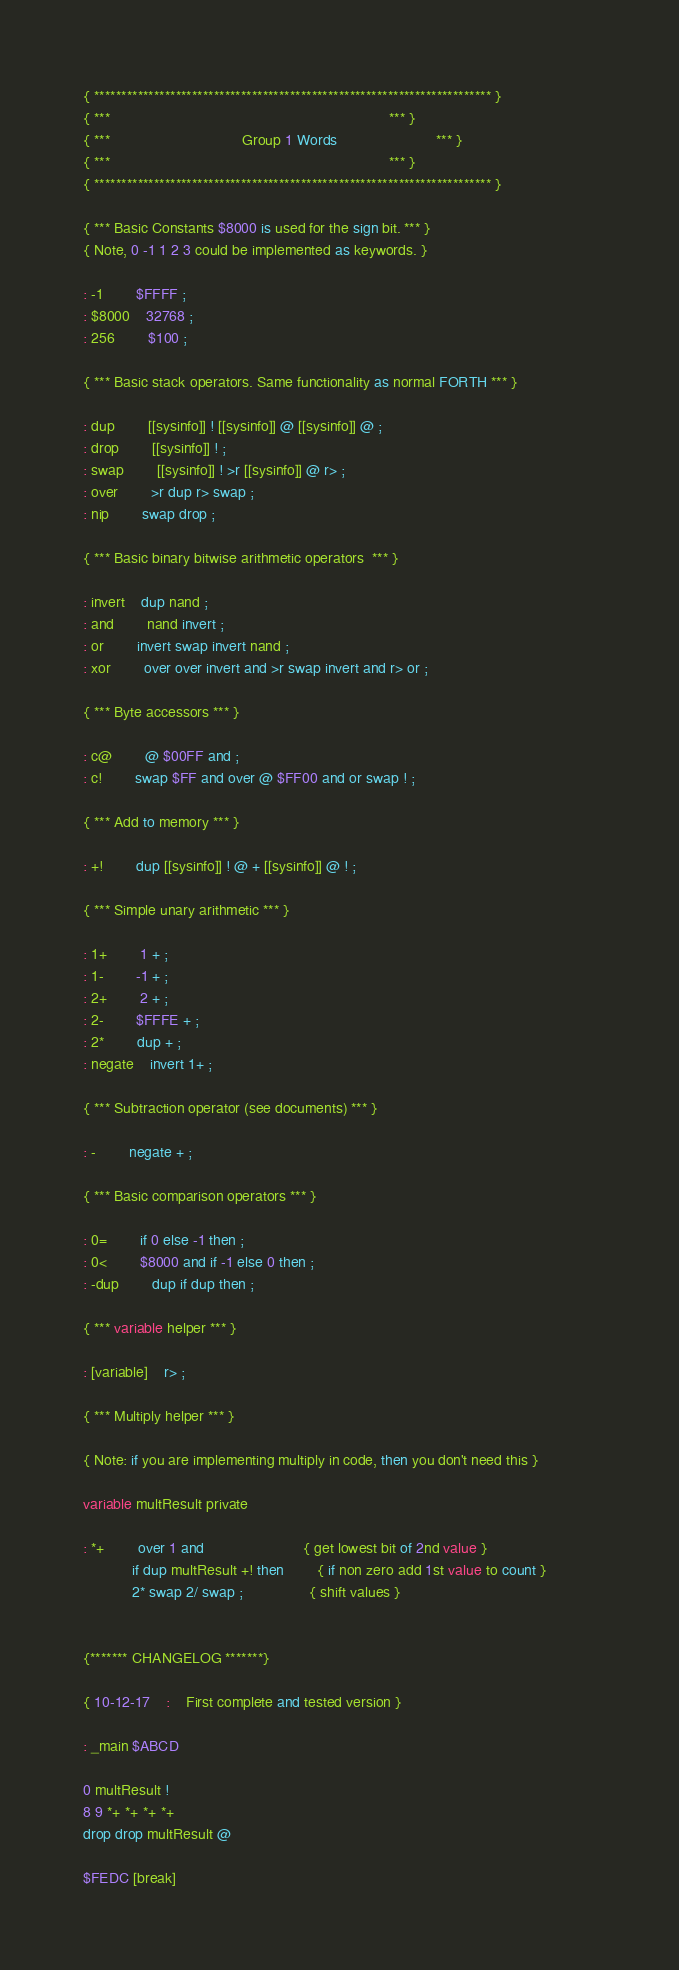<code> <loc_0><loc_0><loc_500><loc_500><_Forth_>{ ************************************************************************* }
{ ***																	*** }
{ ***								Group 1 Words						*** }
{ ***																	*** }
{ ************************************************************************* }

{ *** Basic Constants $8000 is used for the sign bit. *** }
{ Note, 0 -1 1 2 3 could be implemented as keywords. }

: -1 		$FFFF ;
: $8000 	32768 ;
: 256 		$100 ;
	
{ *** Basic stack operators. Same functionality as normal FORTH *** }

: dup		[[sysinfo]] ! [[sysinfo]] @ [[sysinfo]] @ ;
: drop 		[[sysinfo]] ! ;
: swap 		[[sysinfo]] ! >r [[sysinfo]] @ r> ;
: over 		>r dup r> swap ;
: nip 		swap drop ;

{ *** Basic binary bitwise arithmetic operators  *** }

: invert	dup nand ;
: and 		nand invert ;
: or 		invert swap invert nand ;
: xor 		over over invert and >r swap invert and r> or ;

{ *** Byte accessors *** }

: c@ 		@ $00FF and ;
: c! 		swap $FF and over @ $FF00 and or swap ! ;

{ *** Add to memory *** }

: +! 		dup [[sysinfo]] ! @ + [[sysinfo]] @ ! ;

{ *** Simple unary arithmetic *** }

: 1+ 		1 + ;
: 1- 		-1 + ;
: 2+ 		2 + ;
: 2- 		$FFFE + ;
: 2* 		dup + ;
: negate	invert 1+ ;

{ *** Subtraction operator (see documents) *** }

: - 		negate + ;

{ *** Basic comparison operators *** }

: 0=	 	if 0 else -1 then ;
: 0< 		$8000 and if -1 else 0 then ;
: -dup 		dup if dup then ;

{ *** variable helper *** }

: [variable]	r> ;

{ *** Multiply helper *** }			

{ Note: if you are implementing multiply in code, then you don't need this }

variable multResult private

: *+ 		over 1 and 						{ get lowest bit of 2nd value }
			if dup multResult +! then 		{ if non zero add 1st value to count }			
			2* swap 2/ swap ;				{ shift values }


{******* CHANGELOG *******}

{ 10-12-17	: 	First complete and tested version }

: _main $ABCD

0 multResult !
8 9 *+ *+ *+ *+ 
drop drop multResult @

$FEDC [break]</code> 